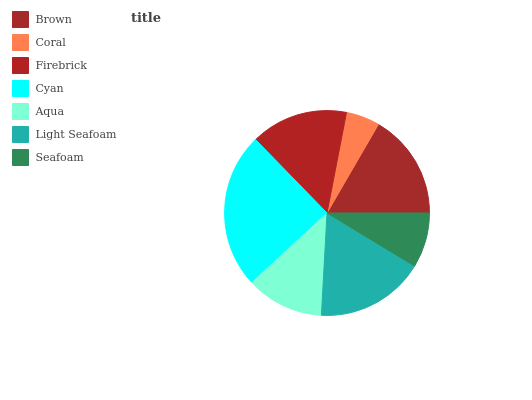Is Coral the minimum?
Answer yes or no. Yes. Is Cyan the maximum?
Answer yes or no. Yes. Is Firebrick the minimum?
Answer yes or no. No. Is Firebrick the maximum?
Answer yes or no. No. Is Firebrick greater than Coral?
Answer yes or no. Yes. Is Coral less than Firebrick?
Answer yes or no. Yes. Is Coral greater than Firebrick?
Answer yes or no. No. Is Firebrick less than Coral?
Answer yes or no. No. Is Firebrick the high median?
Answer yes or no. Yes. Is Firebrick the low median?
Answer yes or no. Yes. Is Brown the high median?
Answer yes or no. No. Is Cyan the low median?
Answer yes or no. No. 